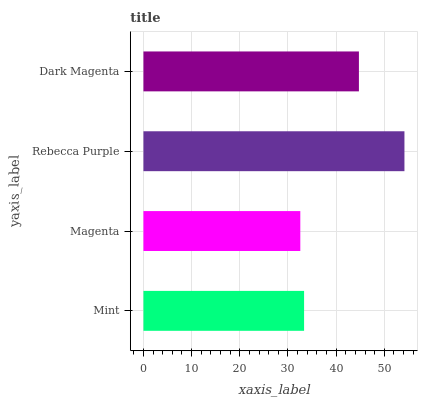Is Magenta the minimum?
Answer yes or no. Yes. Is Rebecca Purple the maximum?
Answer yes or no. Yes. Is Rebecca Purple the minimum?
Answer yes or no. No. Is Magenta the maximum?
Answer yes or no. No. Is Rebecca Purple greater than Magenta?
Answer yes or no. Yes. Is Magenta less than Rebecca Purple?
Answer yes or no. Yes. Is Magenta greater than Rebecca Purple?
Answer yes or no. No. Is Rebecca Purple less than Magenta?
Answer yes or no. No. Is Dark Magenta the high median?
Answer yes or no. Yes. Is Mint the low median?
Answer yes or no. Yes. Is Rebecca Purple the high median?
Answer yes or no. No. Is Rebecca Purple the low median?
Answer yes or no. No. 